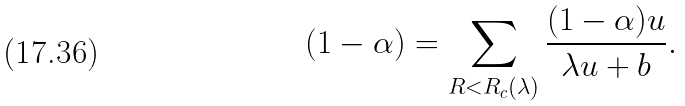<formula> <loc_0><loc_0><loc_500><loc_500>( 1 - \alpha ) = \sum _ { R < R _ { c } ( \lambda ) } \frac { ( 1 - \alpha ) u } { \lambda u + b } .</formula> 